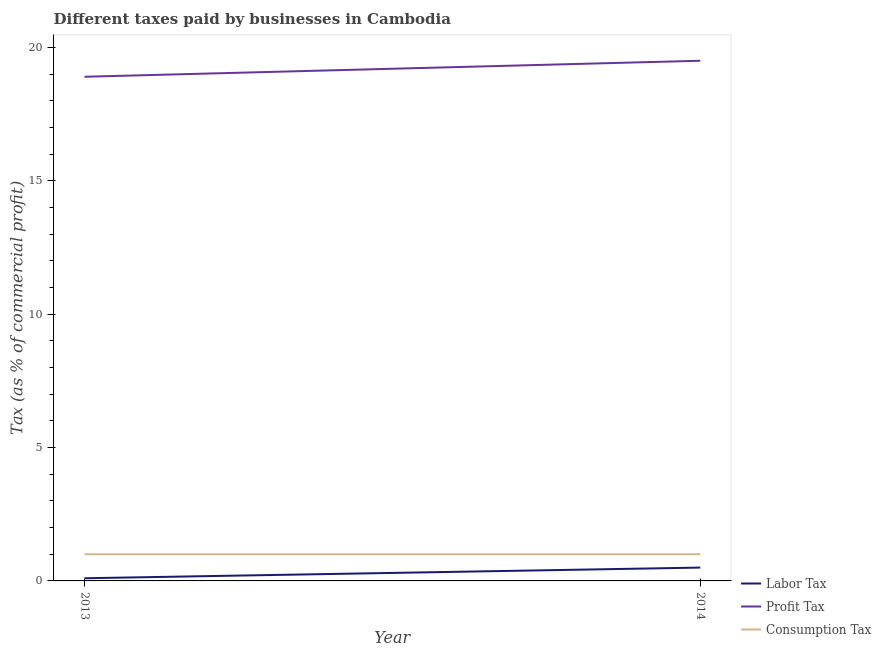Is the number of lines equal to the number of legend labels?
Offer a terse response. Yes. What is the percentage of profit tax in 2014?
Your answer should be compact. 19.5. Across all years, what is the minimum percentage of consumption tax?
Provide a short and direct response. 1. In which year was the percentage of consumption tax maximum?
Your answer should be compact. 2013. In which year was the percentage of consumption tax minimum?
Give a very brief answer. 2013. What is the total percentage of profit tax in the graph?
Keep it short and to the point. 38.4. What is the difference between the percentage of profit tax in 2013 and that in 2014?
Provide a short and direct response. -0.6. What is the difference between the percentage of profit tax in 2013 and the percentage of labor tax in 2014?
Ensure brevity in your answer.  18.4. What is the average percentage of labor tax per year?
Make the answer very short. 0.3. In how many years, is the percentage of labor tax greater than 5 %?
Your response must be concise. 0. What is the ratio of the percentage of consumption tax in 2013 to that in 2014?
Offer a terse response. 1. Is the percentage of profit tax in 2013 less than that in 2014?
Your answer should be very brief. Yes. Is it the case that in every year, the sum of the percentage of labor tax and percentage of profit tax is greater than the percentage of consumption tax?
Provide a short and direct response. Yes. Does the percentage of profit tax monotonically increase over the years?
Give a very brief answer. Yes. Is the percentage of labor tax strictly greater than the percentage of profit tax over the years?
Provide a short and direct response. No. How many lines are there?
Your answer should be compact. 3. Does the graph contain any zero values?
Offer a very short reply. No. Where does the legend appear in the graph?
Provide a short and direct response. Bottom right. How many legend labels are there?
Your answer should be very brief. 3. How are the legend labels stacked?
Keep it short and to the point. Vertical. What is the title of the graph?
Ensure brevity in your answer.  Different taxes paid by businesses in Cambodia. What is the label or title of the X-axis?
Offer a very short reply. Year. What is the label or title of the Y-axis?
Make the answer very short. Tax (as % of commercial profit). What is the Tax (as % of commercial profit) in Labor Tax in 2013?
Provide a succinct answer. 0.1. What is the Tax (as % of commercial profit) in Consumption Tax in 2013?
Make the answer very short. 1. What is the Tax (as % of commercial profit) of Labor Tax in 2014?
Provide a short and direct response. 0.5. What is the Tax (as % of commercial profit) of Profit Tax in 2014?
Your response must be concise. 19.5. What is the Tax (as % of commercial profit) in Consumption Tax in 2014?
Give a very brief answer. 1. Across all years, what is the maximum Tax (as % of commercial profit) in Labor Tax?
Offer a terse response. 0.5. Across all years, what is the minimum Tax (as % of commercial profit) in Profit Tax?
Offer a very short reply. 18.9. What is the total Tax (as % of commercial profit) of Profit Tax in the graph?
Provide a succinct answer. 38.4. What is the total Tax (as % of commercial profit) of Consumption Tax in the graph?
Keep it short and to the point. 2. What is the difference between the Tax (as % of commercial profit) in Labor Tax in 2013 and that in 2014?
Make the answer very short. -0.4. What is the difference between the Tax (as % of commercial profit) in Profit Tax in 2013 and that in 2014?
Ensure brevity in your answer.  -0.6. What is the difference between the Tax (as % of commercial profit) of Labor Tax in 2013 and the Tax (as % of commercial profit) of Profit Tax in 2014?
Your answer should be compact. -19.4. What is the difference between the Tax (as % of commercial profit) in Profit Tax in 2013 and the Tax (as % of commercial profit) in Consumption Tax in 2014?
Your answer should be compact. 17.9. What is the average Tax (as % of commercial profit) of Labor Tax per year?
Make the answer very short. 0.3. What is the average Tax (as % of commercial profit) of Profit Tax per year?
Make the answer very short. 19.2. What is the average Tax (as % of commercial profit) in Consumption Tax per year?
Ensure brevity in your answer.  1. In the year 2013, what is the difference between the Tax (as % of commercial profit) of Labor Tax and Tax (as % of commercial profit) of Profit Tax?
Keep it short and to the point. -18.8. In the year 2014, what is the difference between the Tax (as % of commercial profit) of Labor Tax and Tax (as % of commercial profit) of Profit Tax?
Provide a succinct answer. -19. What is the ratio of the Tax (as % of commercial profit) in Profit Tax in 2013 to that in 2014?
Keep it short and to the point. 0.97. What is the ratio of the Tax (as % of commercial profit) of Consumption Tax in 2013 to that in 2014?
Your answer should be compact. 1. 